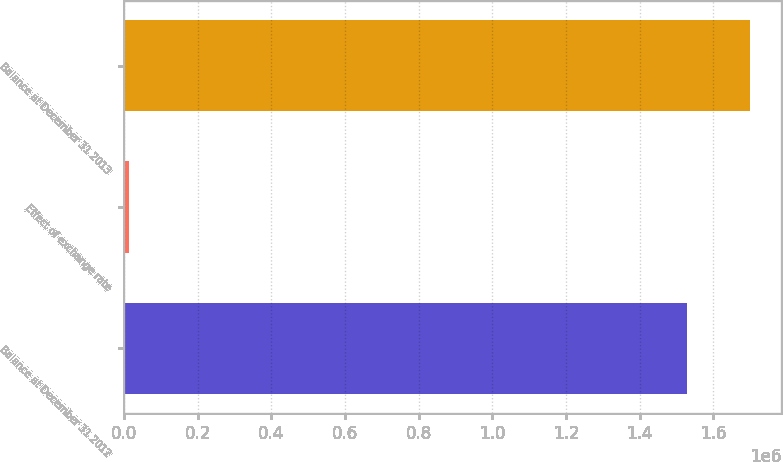Convert chart. <chart><loc_0><loc_0><loc_500><loc_500><bar_chart><fcel>Balance at December 31 2012<fcel>Effect of exchange rate<fcel>Balance at December 31 2013<nl><fcel>1.52821e+06<fcel>14250<fcel>1.69861e+06<nl></chart> 